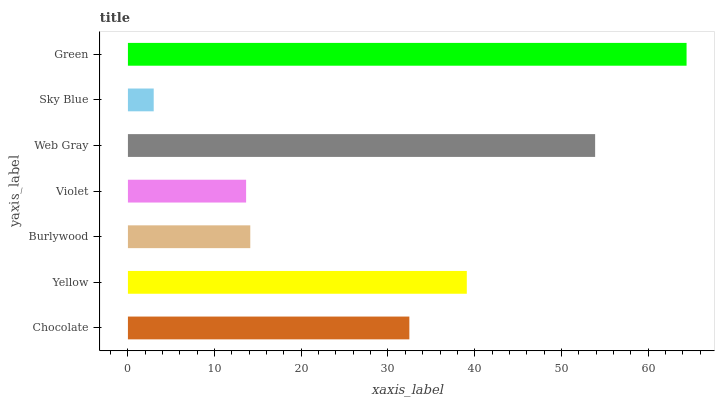Is Sky Blue the minimum?
Answer yes or no. Yes. Is Green the maximum?
Answer yes or no. Yes. Is Yellow the minimum?
Answer yes or no. No. Is Yellow the maximum?
Answer yes or no. No. Is Yellow greater than Chocolate?
Answer yes or no. Yes. Is Chocolate less than Yellow?
Answer yes or no. Yes. Is Chocolate greater than Yellow?
Answer yes or no. No. Is Yellow less than Chocolate?
Answer yes or no. No. Is Chocolate the high median?
Answer yes or no. Yes. Is Chocolate the low median?
Answer yes or no. Yes. Is Sky Blue the high median?
Answer yes or no. No. Is Burlywood the low median?
Answer yes or no. No. 